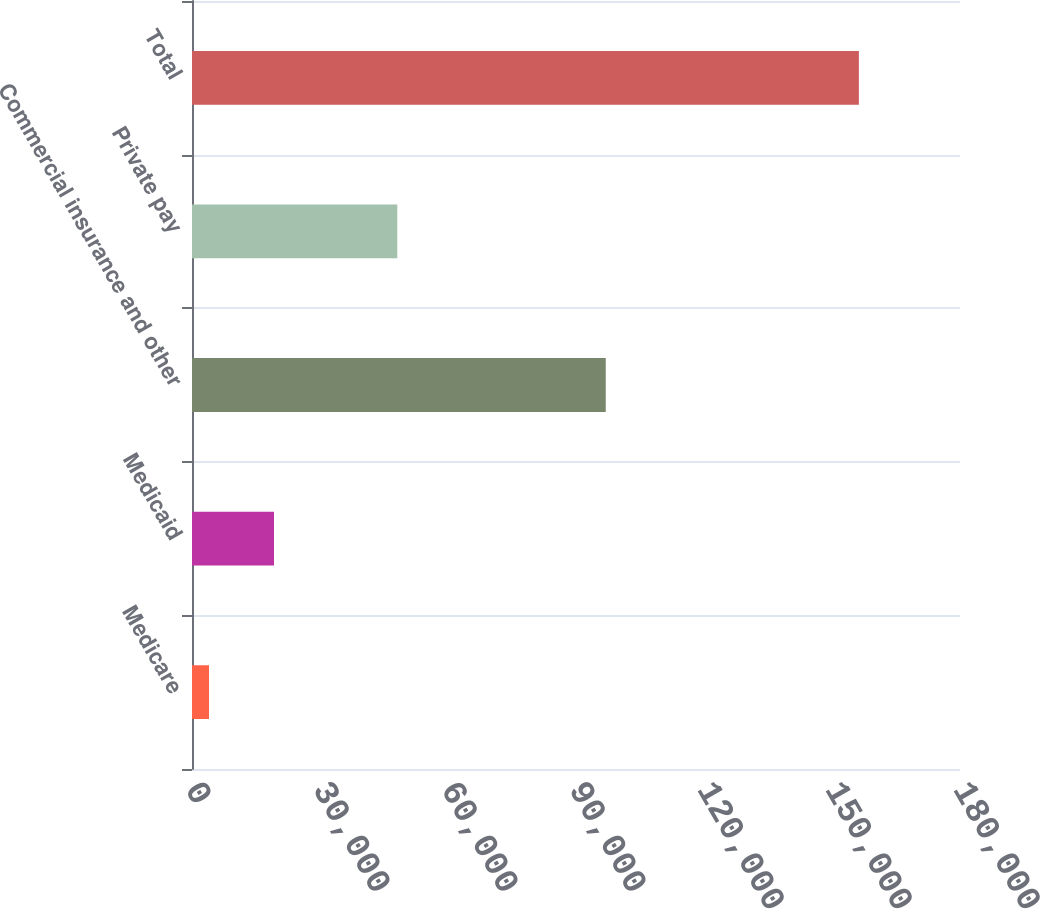Convert chart. <chart><loc_0><loc_0><loc_500><loc_500><bar_chart><fcel>Medicare<fcel>Medicaid<fcel>Commercial insurance and other<fcel>Private pay<fcel>Total<nl><fcel>3988<fcel>19219.1<fcel>96973<fcel>48112<fcel>156299<nl></chart> 